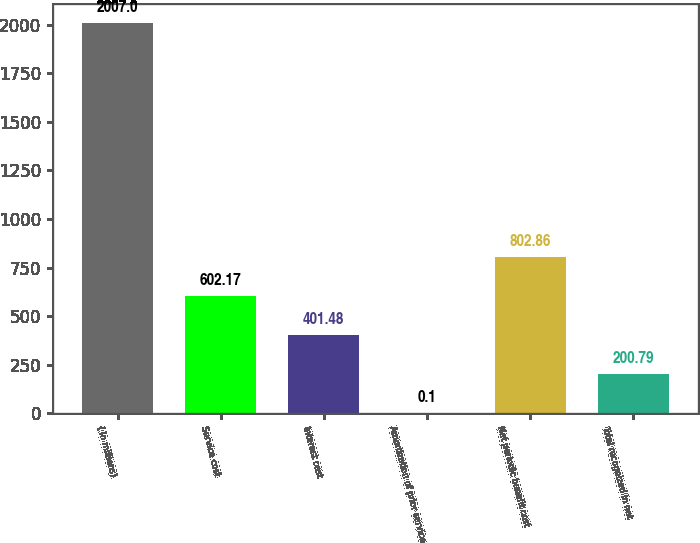Convert chart to OTSL. <chart><loc_0><loc_0><loc_500><loc_500><bar_chart><fcel>( in millions)<fcel>Service cost<fcel>Interest cost<fcel>Amortization of prior service<fcel>Net periodic benefit cost<fcel>Total recognized in net<nl><fcel>2007<fcel>602.17<fcel>401.48<fcel>0.1<fcel>802.86<fcel>200.79<nl></chart> 